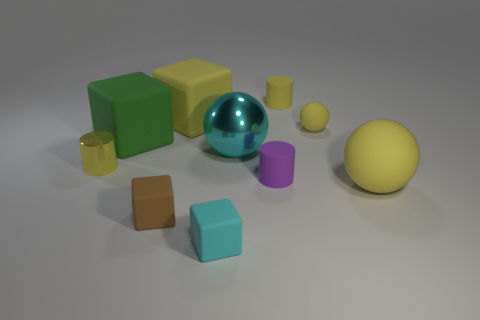Subtract all spheres. How many objects are left? 7 Subtract all small cyan matte things. Subtract all brown blocks. How many objects are left? 8 Add 5 tiny yellow rubber cylinders. How many tiny yellow rubber cylinders are left? 6 Add 1 tiny purple matte blocks. How many tiny purple matte blocks exist? 1 Subtract 0 blue blocks. How many objects are left? 10 